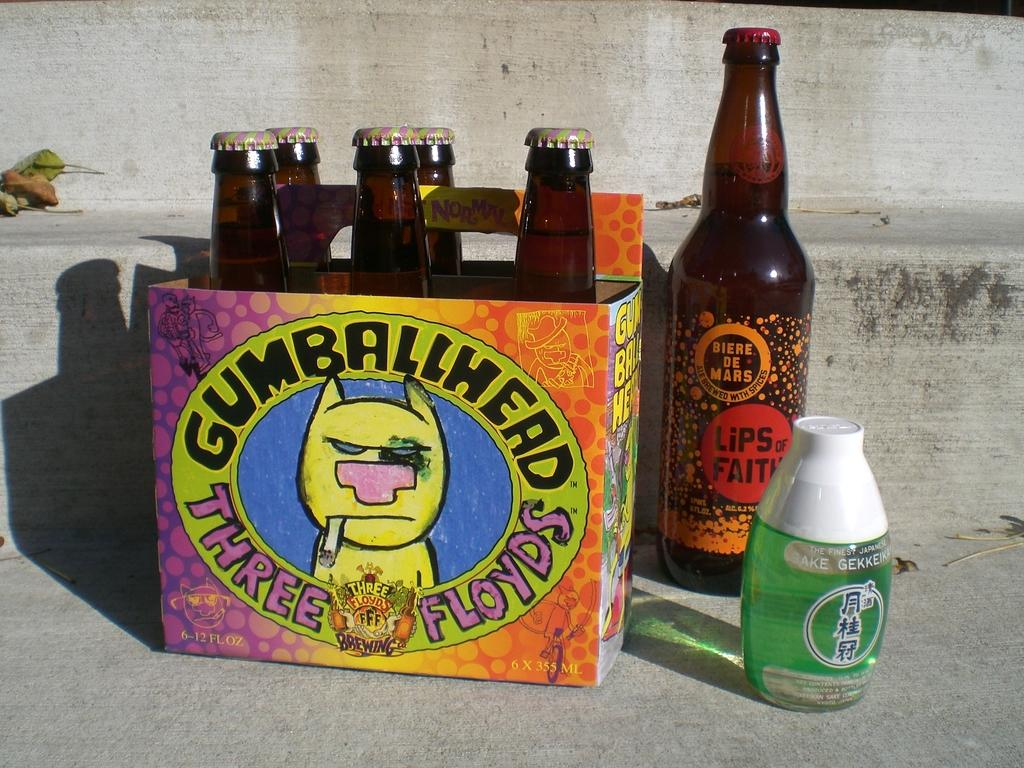<image>
Render a clear and concise summary of the photo. Case of Gumballhead Three Floyds beer outdoors on a step. 